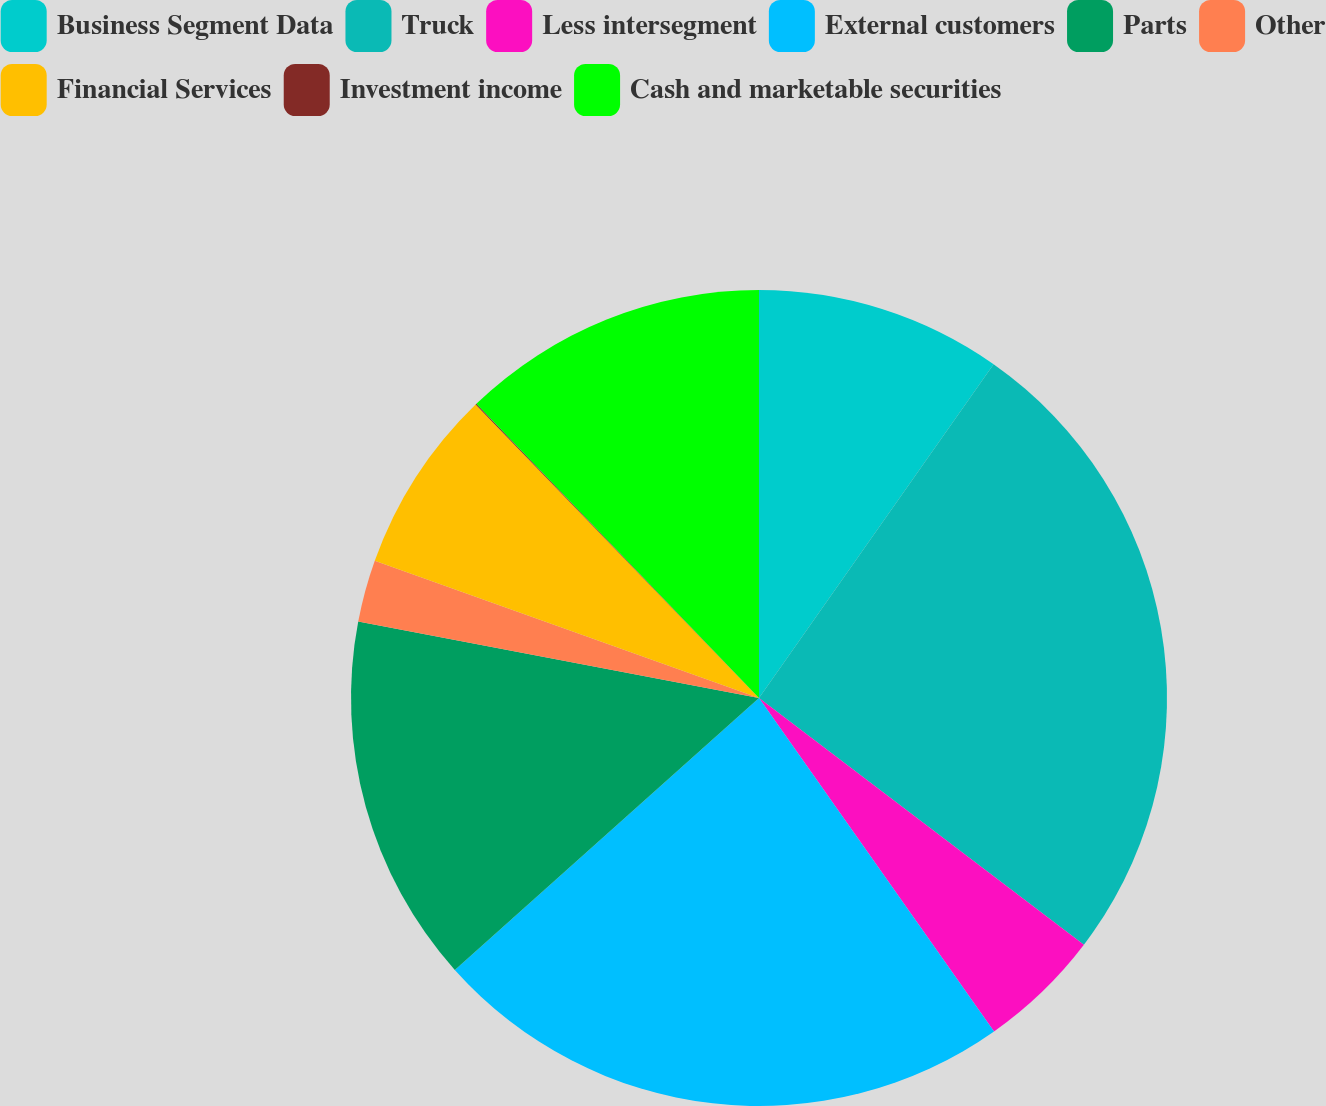Convert chart. <chart><loc_0><loc_0><loc_500><loc_500><pie_chart><fcel>Business Segment Data<fcel>Truck<fcel>Less intersegment<fcel>External customers<fcel>Parts<fcel>Other<fcel>Financial Services<fcel>Investment income<fcel>Cash and marketable securities<nl><fcel>9.75%<fcel>25.59%<fcel>4.89%<fcel>23.16%<fcel>14.61%<fcel>2.46%<fcel>7.32%<fcel>0.04%<fcel>12.18%<nl></chart> 